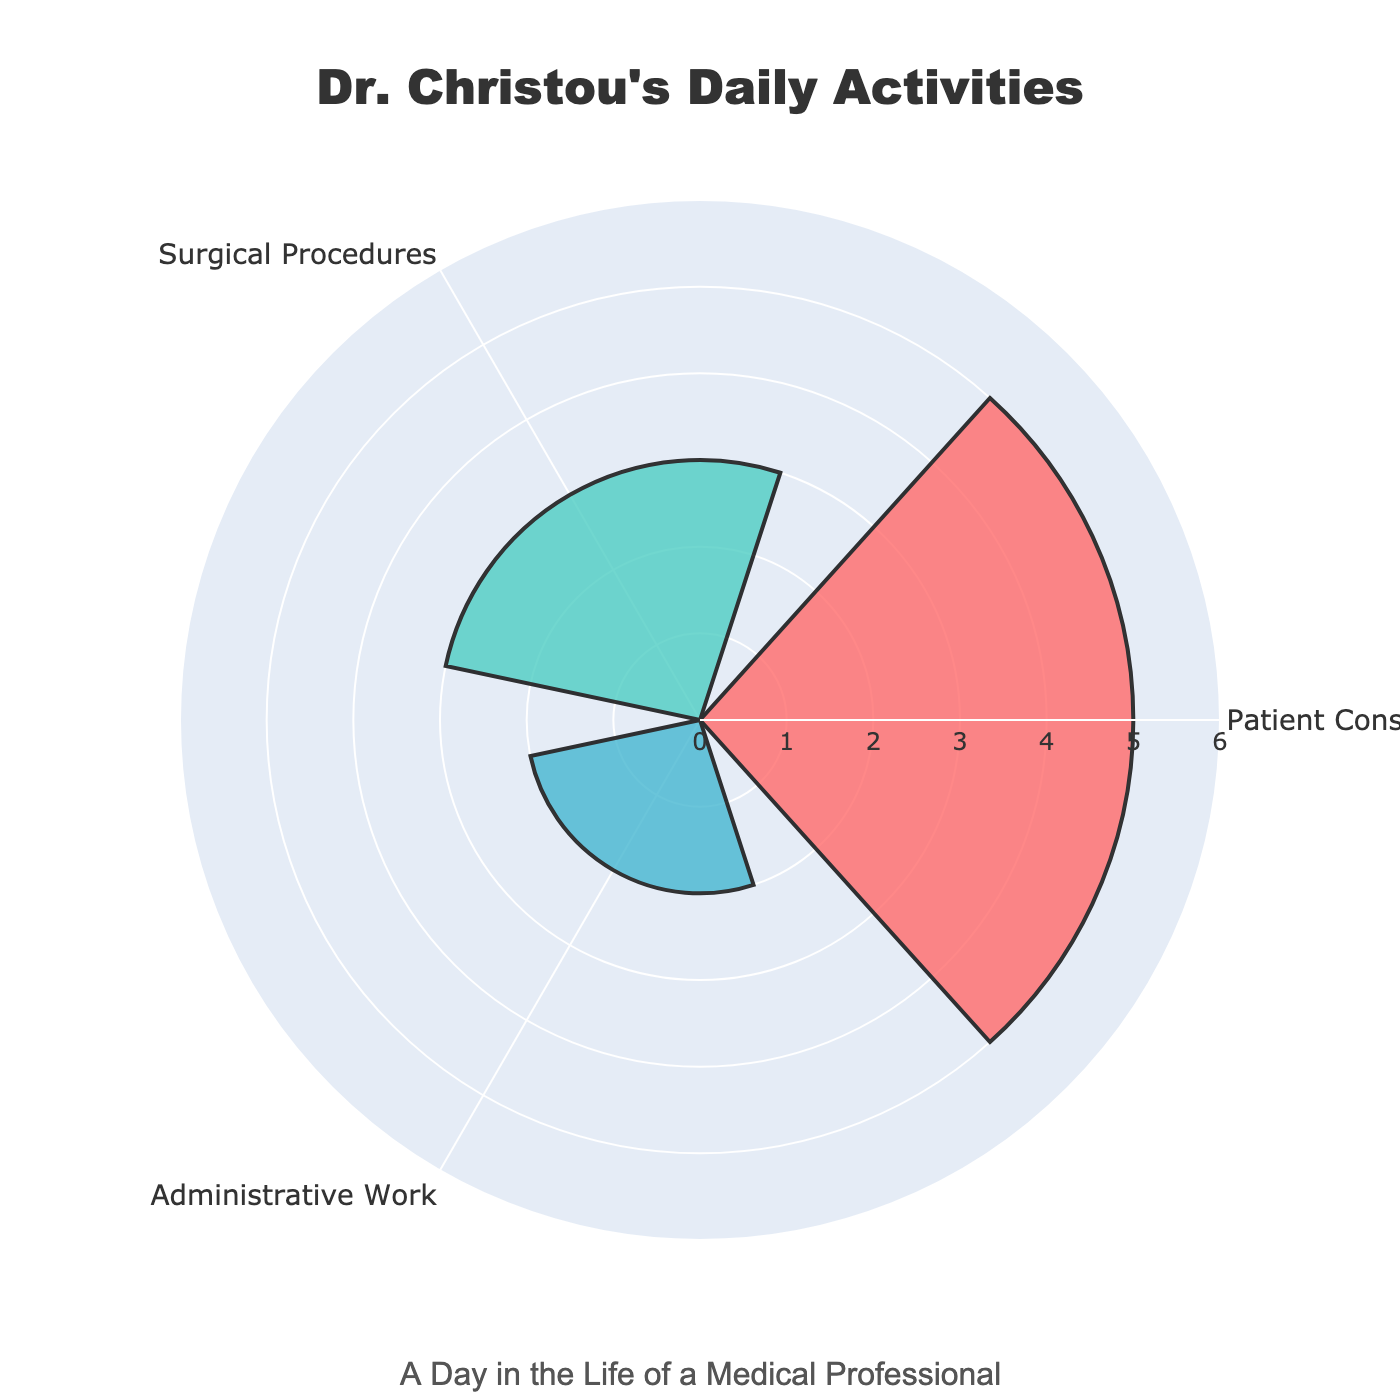What are the activities shown in the chart? The chart displays three activities. They are listed around the circular plot and correspond to the values represented by the bars.
Answer: Patient Consultations, Surgical Procedures, Administrative Work How many hours are spent on Patient Consultations? The radial distance of the bar labeled “Patient Consultations” represents the time spent on this activity. It shows the largest bar length in the chart.
Answer: 5 hours Which activity has the least amount of time spent on it? Comparing the length of the three bars, the shortest bar corresponds to the activity “Administrative Work”.
Answer: Administrative Work What is the title of the chart? The title is prominently displayed at the top center of the chart.
Answer: Dr. Christou's Daily Activities What is the total time spent on the three activities shown? Summing up the hours spent on the three activities: 5 (Patient Consultations) + 3 (Surgical Procedures) + 2 (Administrative Work) = 10 hours.
Answer: 10 hours How much more time is spent on Patient Consultations than Administrative Work? Subtract the time spent on Administrative Work from the time spent on Patient Consultations: 5 - 2 = 3 hours.
Answer: 3 hours Which activity is represented by the bar with the teal color? Observing the colors of the bars, the teal-colored bar corresponds to “Surgical Procedures”.
Answer: Surgical Procedures What is the average time spent across the three activities? To find the average, sum the hours of the three activities and divide by the number of activities: (5 + 3 + 2) / 3 = 10 / 3 ≈ 3.33 hours.
Answer: ≈ 3.33 hours Which activity takes up the second most amount of time? By process of elimination and observing the bar lengths, the second longest bar corresponds to “Surgical Procedures”.
Answer: Surgical Procedures 